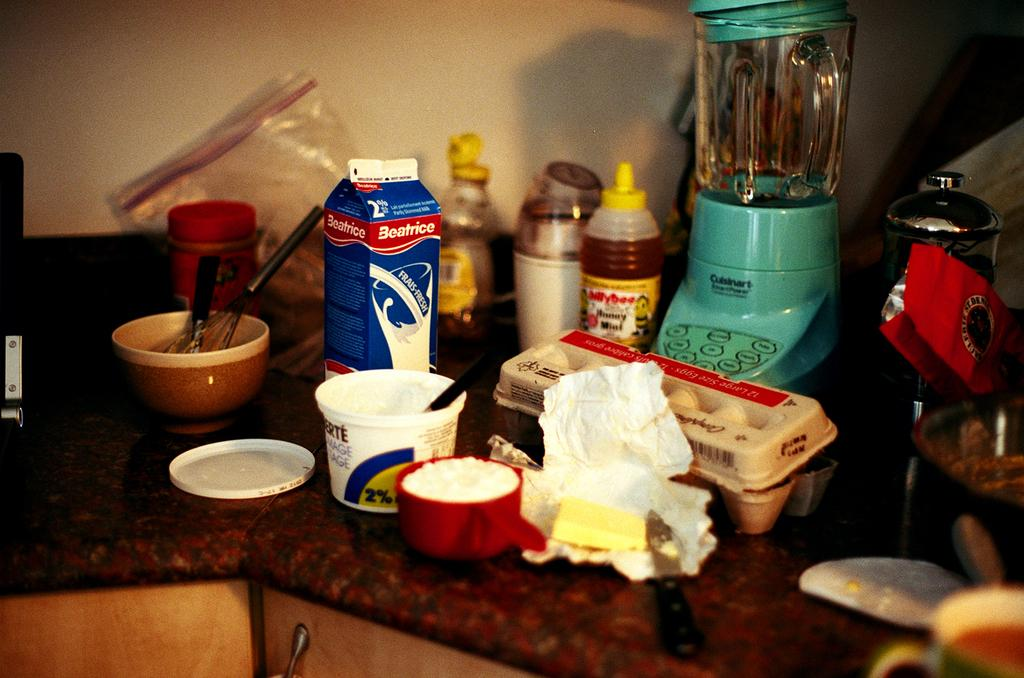What type of floor is shown in the image? The image depicts a kitchen floor. What can be found above the kitchen floor in the image? Cooking items are present above the kitchen floor. What month is depicted in the image? The image does not depict a month; it shows a kitchen floor and cooking items. Can you see a nest in the image? There is no nest present in the image. 